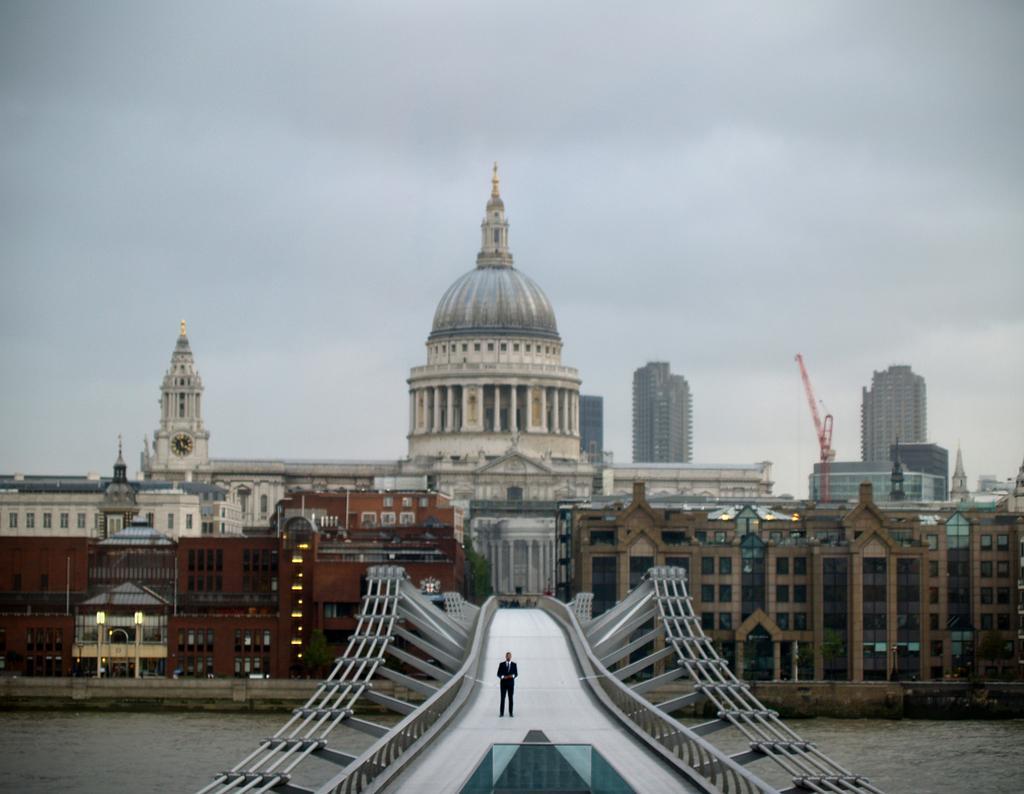In one or two sentences, can you explain what this image depicts? In this picture we can see a person standing on a bridge. There is water visible under the bridge. There is a clock visible in a white building. We can see some lights in the buildings. We can see a few buildings and a crane in the background. Sky is cloudy. 